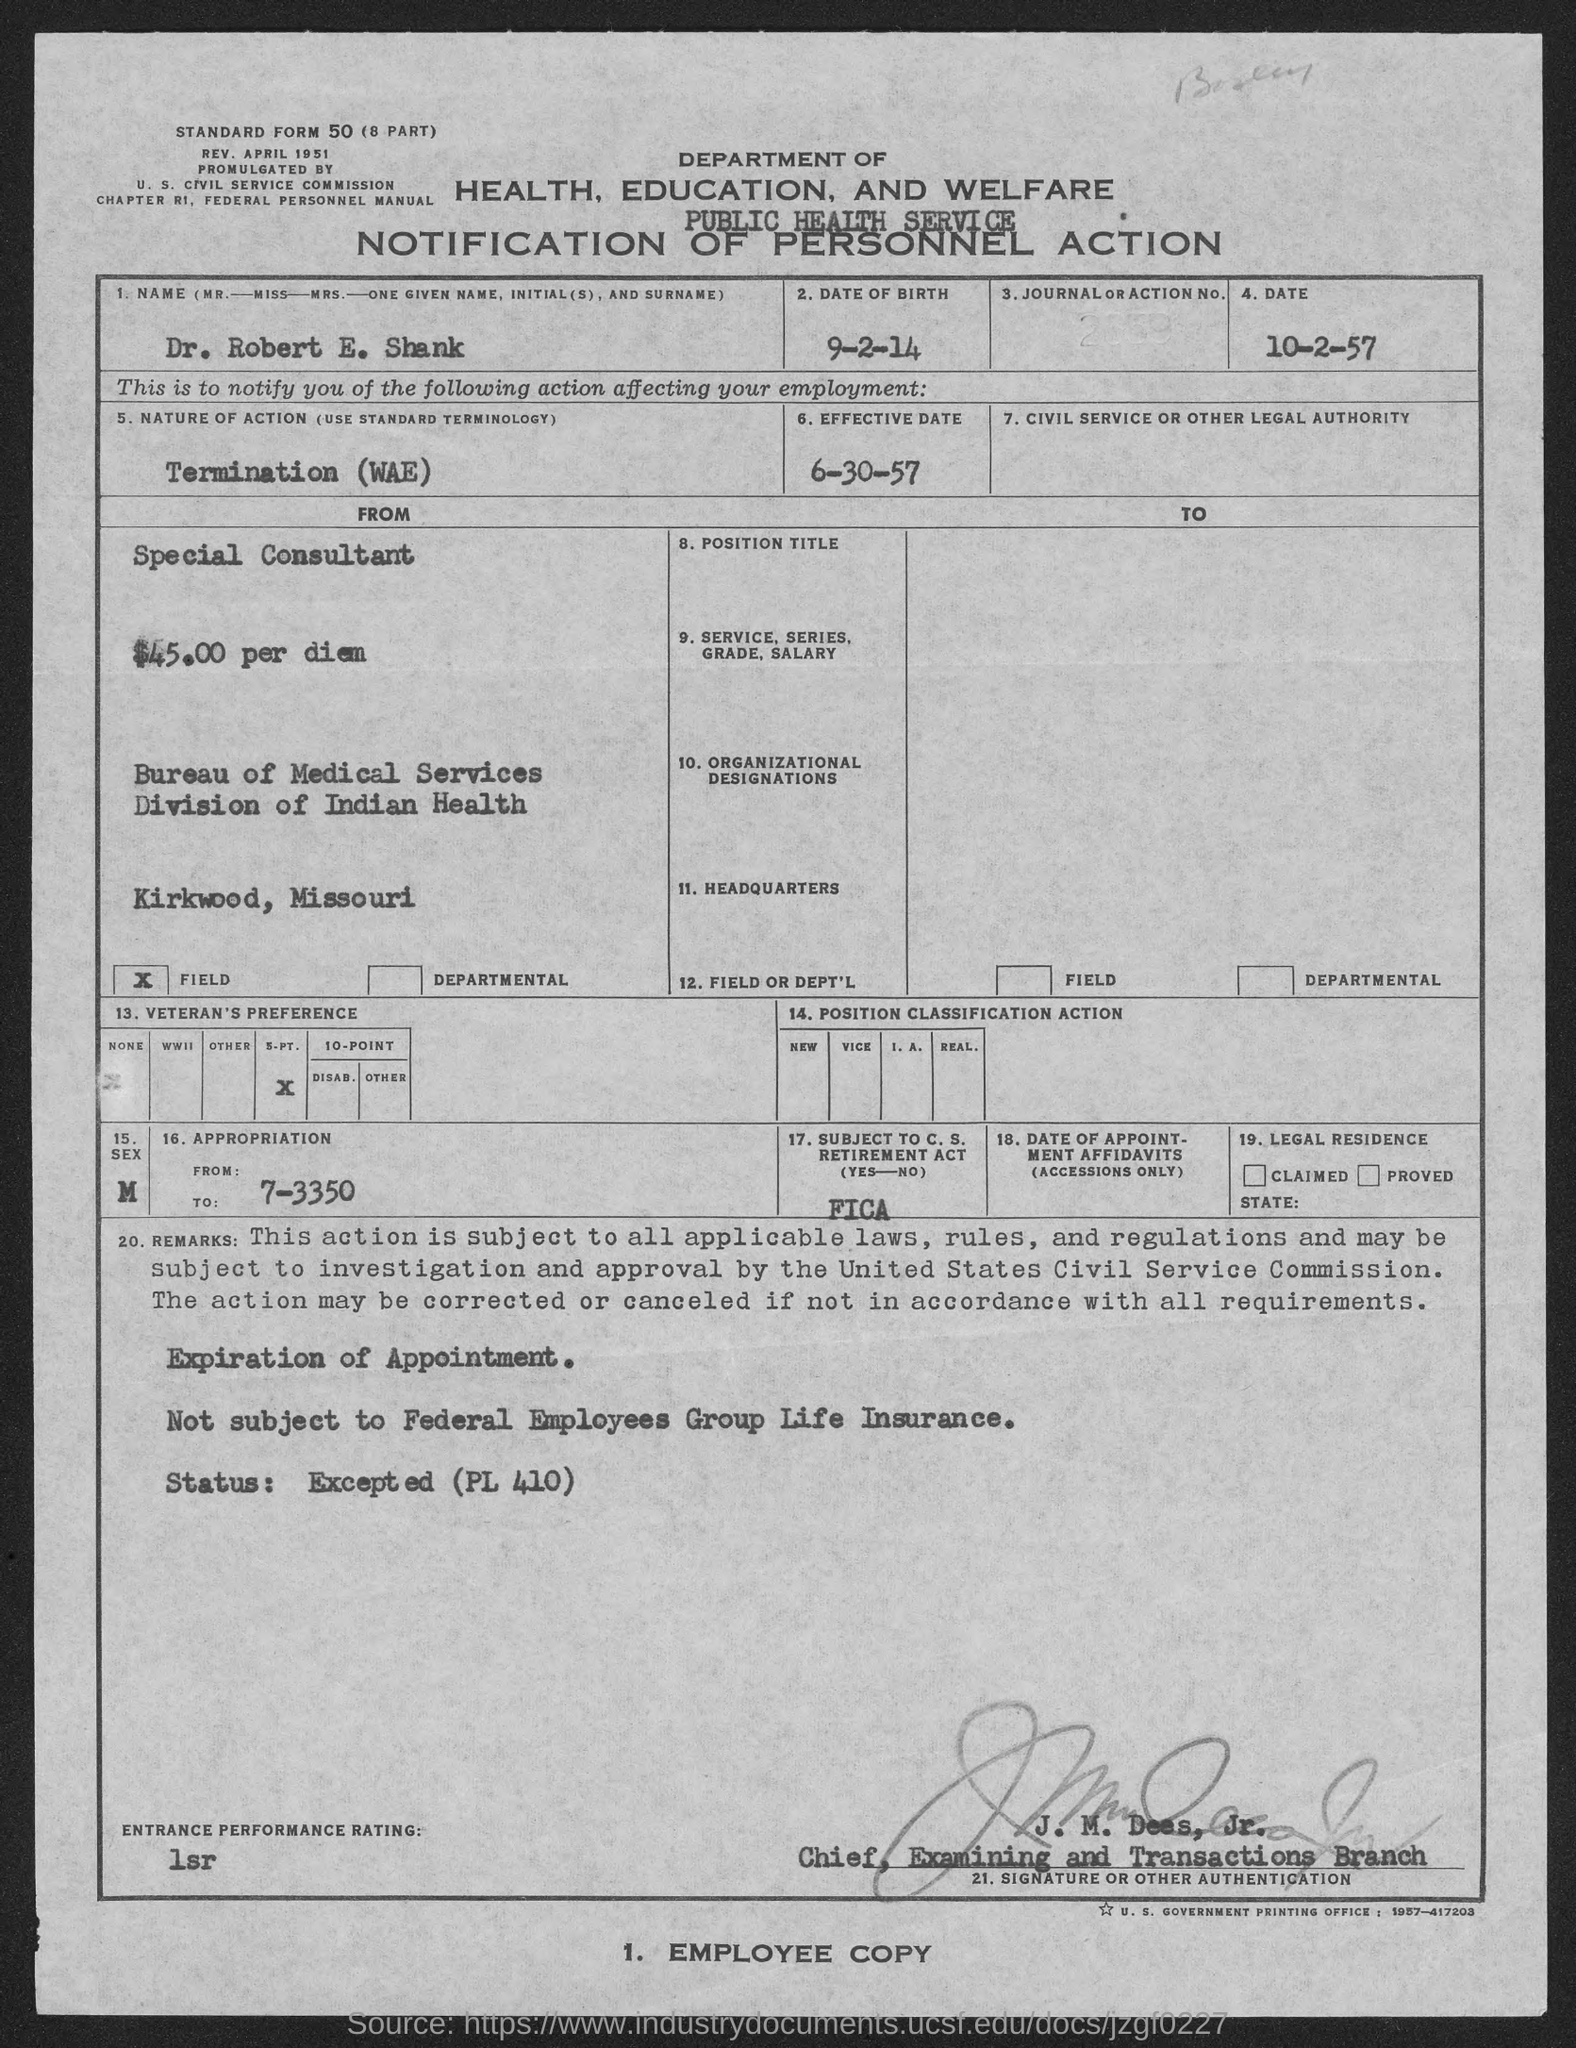What is the nature of action?
Keep it short and to the point. Termination (WAE). What is the name of the candidate?
Keep it short and to the point. Dr. Robert E. Shank. What is the date of birth ?
Make the answer very short. 9-2-14. What is the effective date?
Keep it short and to the point. 6-30-57. 